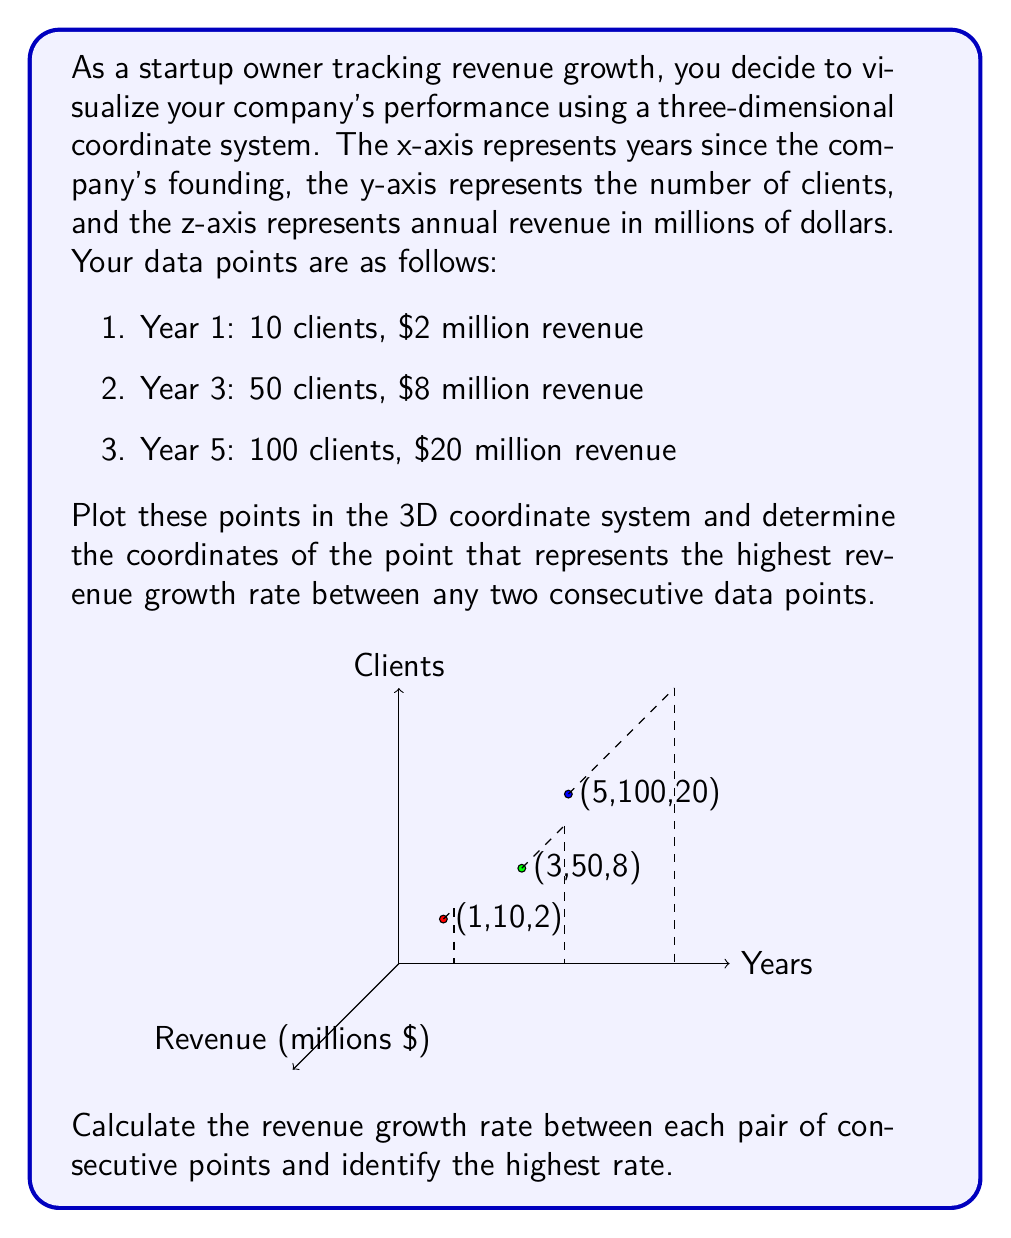Can you answer this question? Let's approach this step-by-step:

1) First, we need to calculate the revenue growth rate between each pair of consecutive points. The revenue growth rate can be calculated using the formula:

   $$ \text{Growth Rate} = \frac{\text{Final Value} - \text{Initial Value}}{\text{Initial Value} \times \text{Time Period}} $$

2) For the period between Year 1 and Year 3:
   $$ \text{Growth Rate}_1 = \frac{8 - 2}{2 \times (3-1)} = \frac{6}{4} = 1.5 \text{ or } 150\% \text{ per year} $$

3) For the period between Year 3 and Year 5:
   $$ \text{Growth Rate}_2 = \frac{20 - 8}{8 \times (5-3)} = \frac{12}{16} = 0.75 \text{ or } 75\% \text{ per year} $$

4) Comparing these two growth rates, we can see that the highest growth rate occurred between Year 1 and Year 3.

5) The point representing the end of this highest growth period is (3, 50, 8), corresponding to Year 3 with 50 clients and $8 million in revenue.

Therefore, the coordinates of the point representing the highest revenue growth rate are (3, 50, 8).
Answer: (3, 50, 8) 